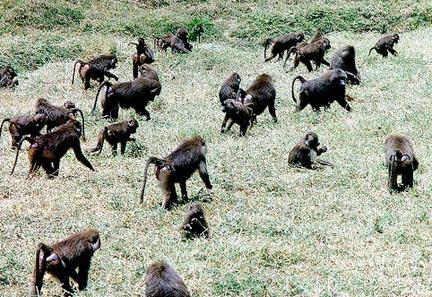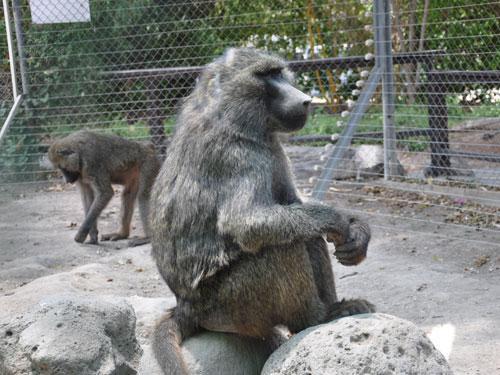The first image is the image on the left, the second image is the image on the right. Given the left and right images, does the statement "An image shows a horizontal row of no more than four baboons of the same size, crouching with some food." hold true? Answer yes or no. No. The first image is the image on the left, the second image is the image on the right. Considering the images on both sides, is "In the image to the right, there are less than six animals." valid? Answer yes or no. Yes. 